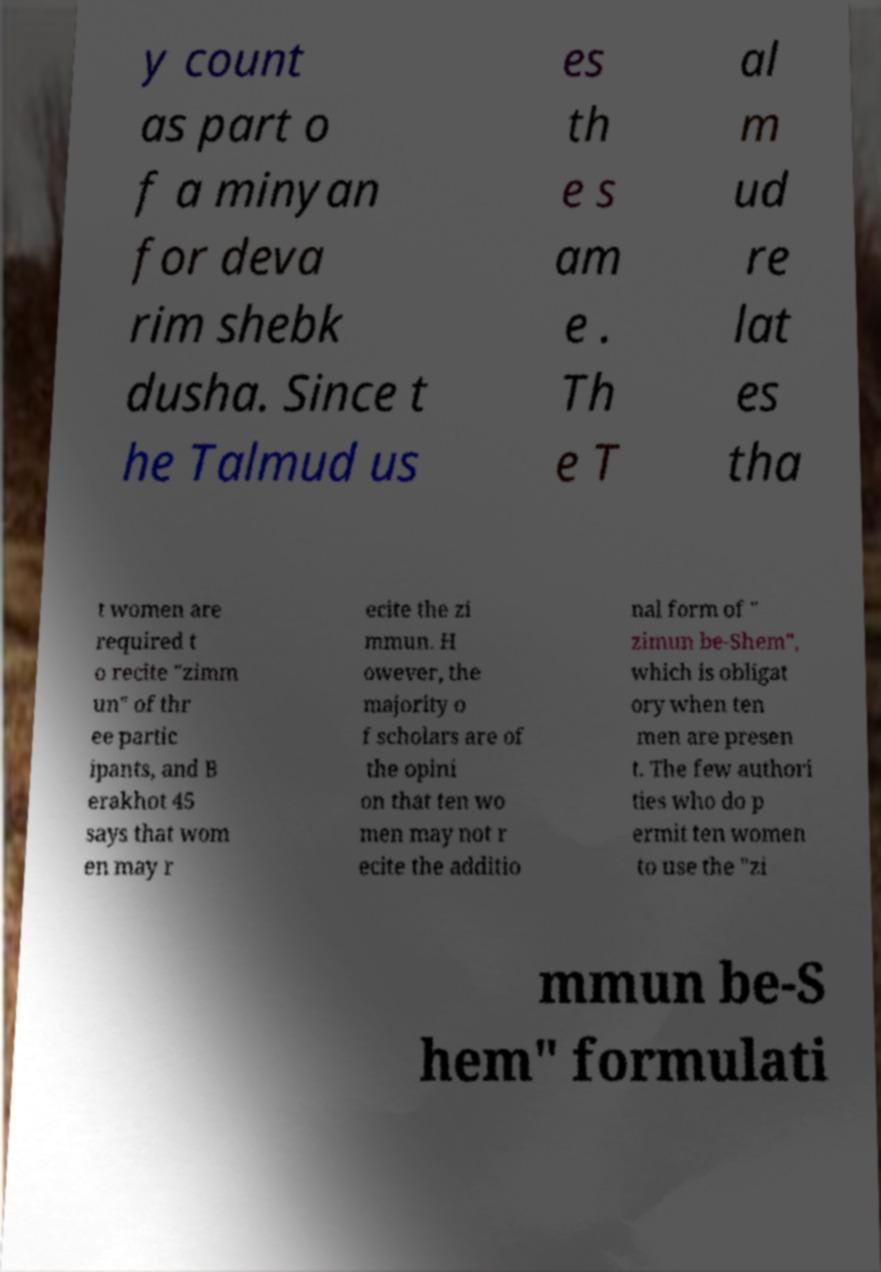Please identify and transcribe the text found in this image. y count as part o f a minyan for deva rim shebk dusha. Since t he Talmud us es th e s am e . Th e T al m ud re lat es tha t women are required t o recite "zimm un" of thr ee partic ipants, and B erakhot 45 says that wom en may r ecite the zi mmun. H owever, the majority o f scholars are of the opini on that ten wo men may not r ecite the additio nal form of " zimun be-Shem", which is obligat ory when ten men are presen t. The few authori ties who do p ermit ten women to use the "zi mmun be-S hem" formulati 